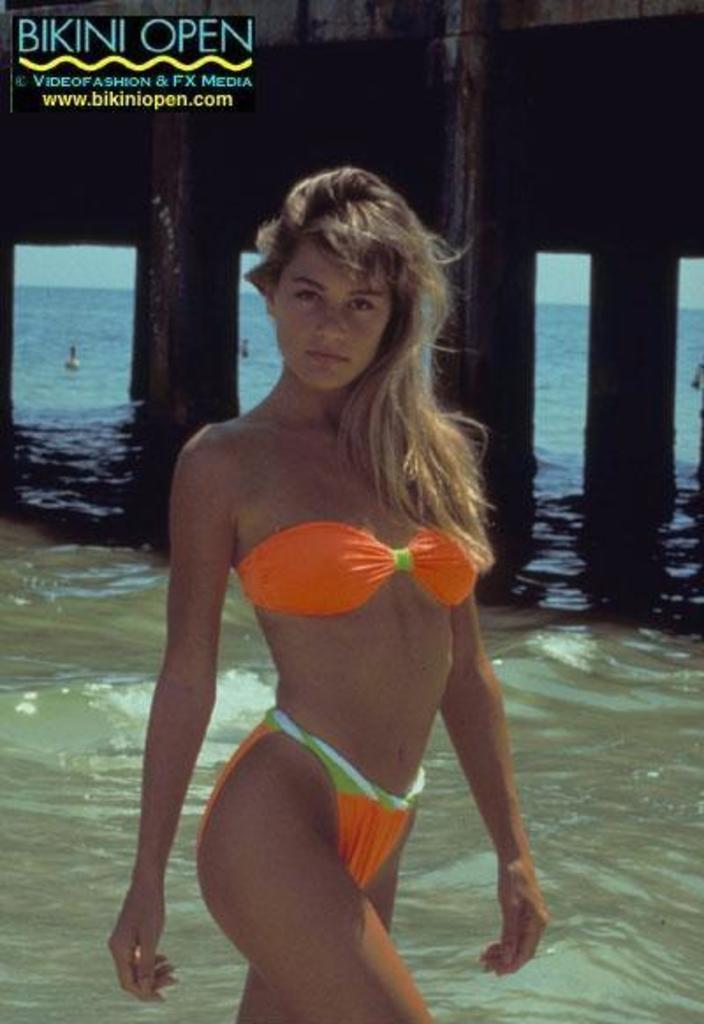How would you summarize this image in a sentence or two? This image consists of a girl in the middle. There is water behind her. 